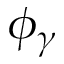Convert formula to latex. <formula><loc_0><loc_0><loc_500><loc_500>\phi _ { \gamma }</formula> 